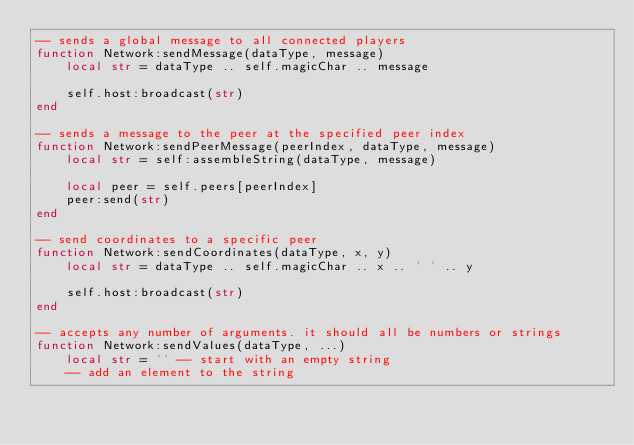Convert code to text. <code><loc_0><loc_0><loc_500><loc_500><_Lua_>-- sends a global message to all connected players
function Network:sendMessage(dataType, message)
	local str = dataType .. self.magicChar .. message

	self.host:broadcast(str)
end

-- sends a message to the peer at the specified peer index
function Network:sendPeerMessage(peerIndex, dataType, message)
	local str = self:assembleString(dataType, message)

	local peer = self.peers[peerIndex]
	peer:send(str)
end

-- send coordinates to a specific peer
function Network:sendCoordinates(dataType, x, y)
	local str = dataType .. self.magicChar .. x .. ' ' .. y

	self.host:broadcast(str)
end

-- accepts any number of arguments. it should all be numbers or strings
function Network:sendValues(dataType, ...)
	local str = '' -- start with an empty string
	-- add an element to the string</code> 